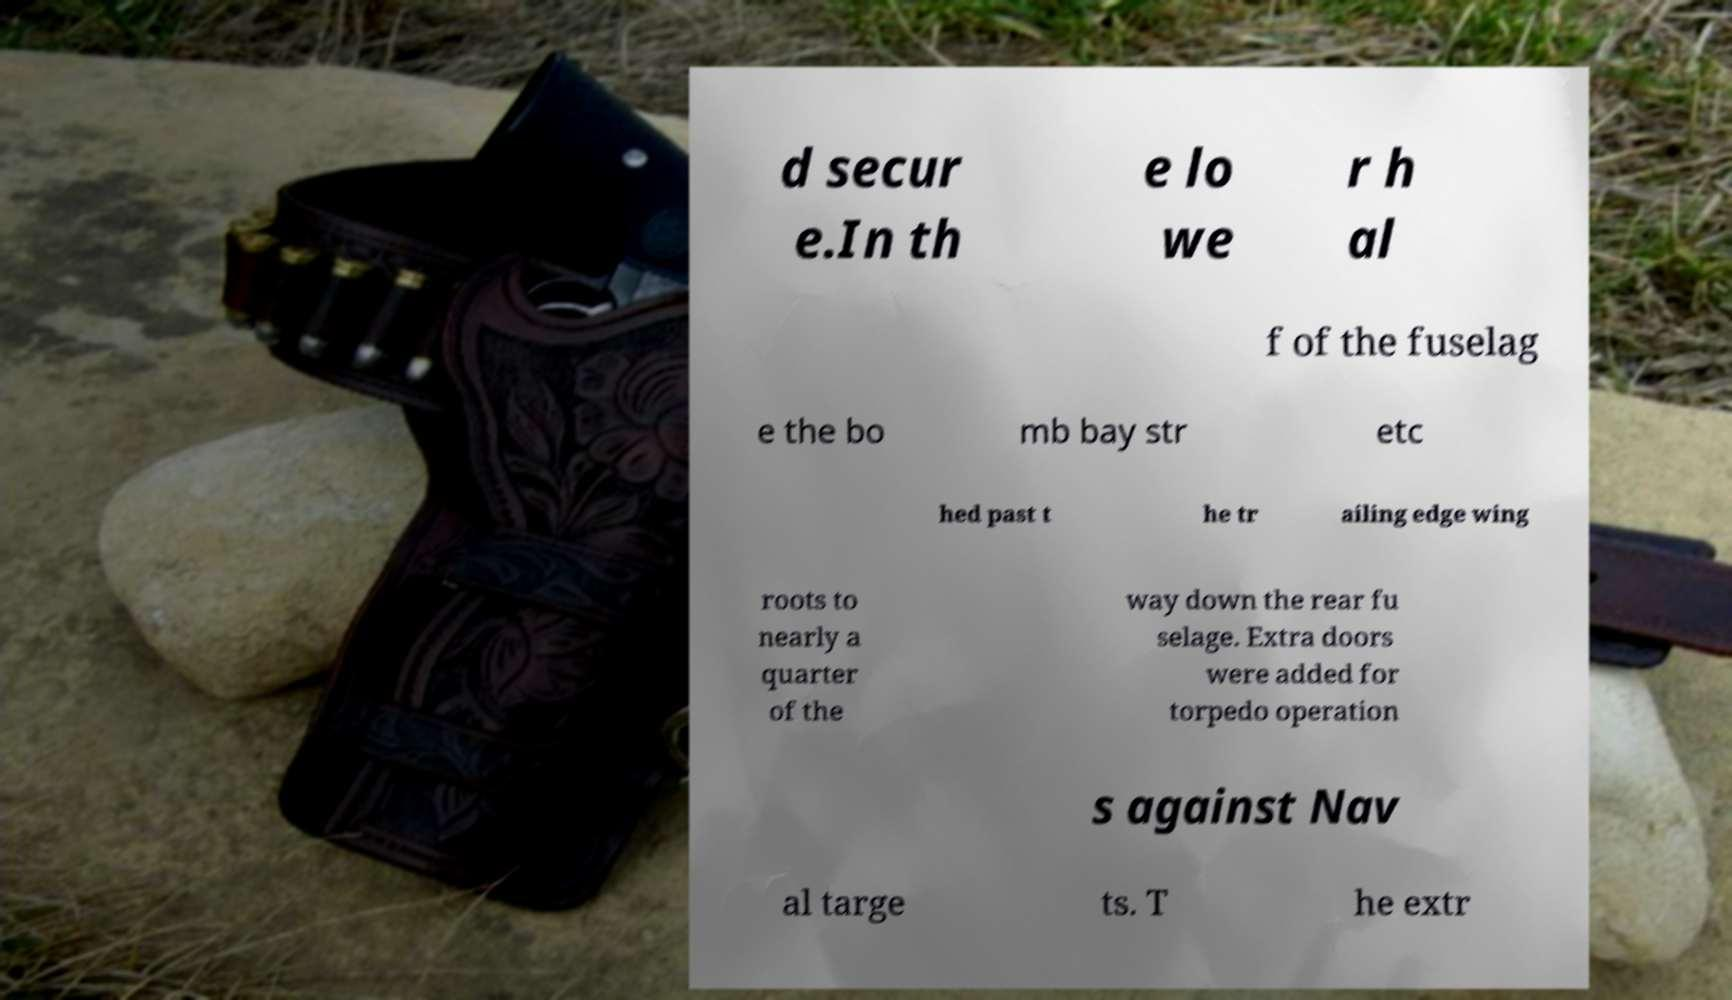Could you extract and type out the text from this image? d secur e.In th e lo we r h al f of the fuselag e the bo mb bay str etc hed past t he tr ailing edge wing roots to nearly a quarter of the way down the rear fu selage. Extra doors were added for torpedo operation s against Nav al targe ts. T he extr 